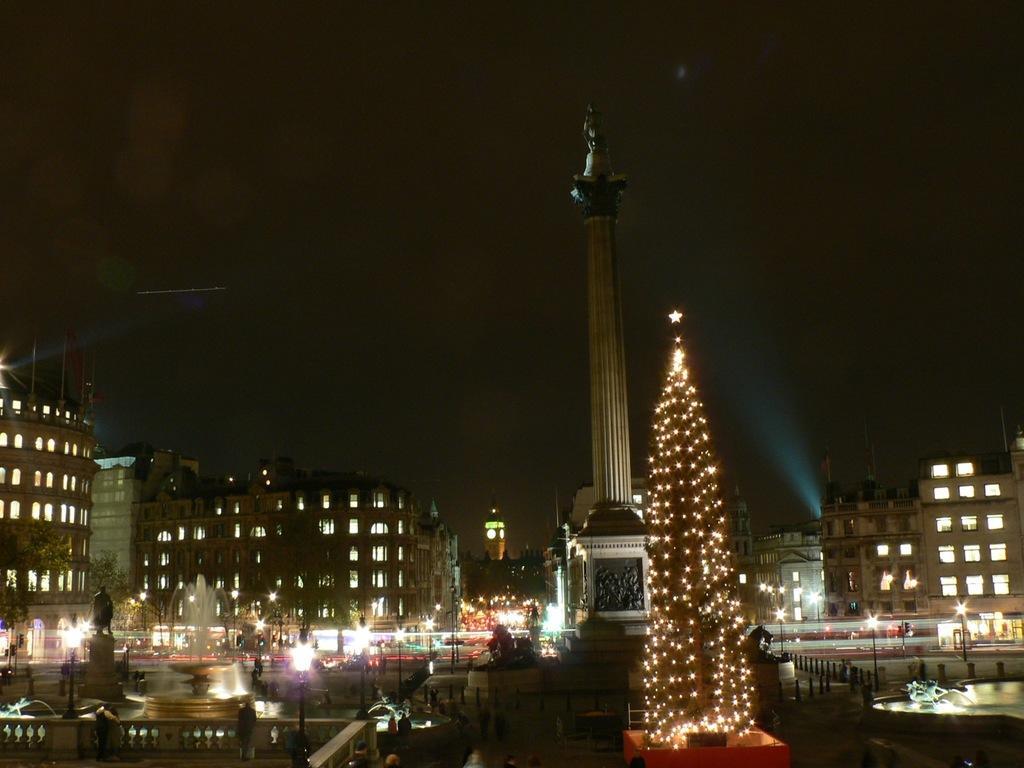Please provide a concise description of this image. In this image there are buildings and we can see poles. There are lights. We can see sculptures. There is an xmas tree. In the background there is sky and we can see a tower. 